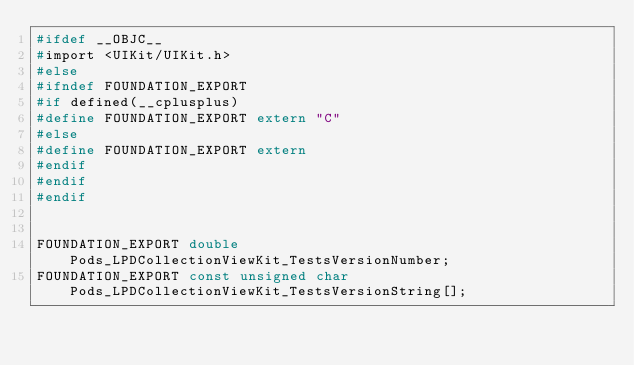<code> <loc_0><loc_0><loc_500><loc_500><_C_>#ifdef __OBJC__
#import <UIKit/UIKit.h>
#else
#ifndef FOUNDATION_EXPORT
#if defined(__cplusplus)
#define FOUNDATION_EXPORT extern "C"
#else
#define FOUNDATION_EXPORT extern
#endif
#endif
#endif


FOUNDATION_EXPORT double Pods_LPDCollectionViewKit_TestsVersionNumber;
FOUNDATION_EXPORT const unsigned char Pods_LPDCollectionViewKit_TestsVersionString[];

</code> 